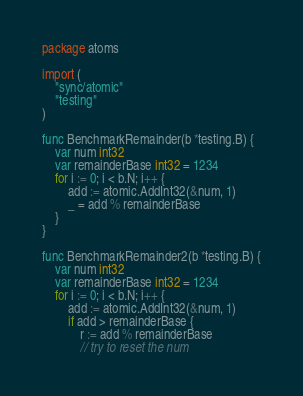<code> <loc_0><loc_0><loc_500><loc_500><_Go_>package atoms

import (
	"sync/atomic"
	"testing"
)

func BenchmarkRemainder(b *testing.B) {
	var num int32
	var remainderBase int32 = 1234
	for i := 0; i < b.N; i++ {
		add := atomic.AddInt32(&num, 1)
		_ = add % remainderBase
	}
}

func BenchmarkRemainder2(b *testing.B) {
	var num int32
	var remainderBase int32 = 1234
	for i := 0; i < b.N; i++ {
		add := atomic.AddInt32(&num, 1)
		if add > remainderBase {
			r := add % remainderBase
			// try to reset the num</code> 